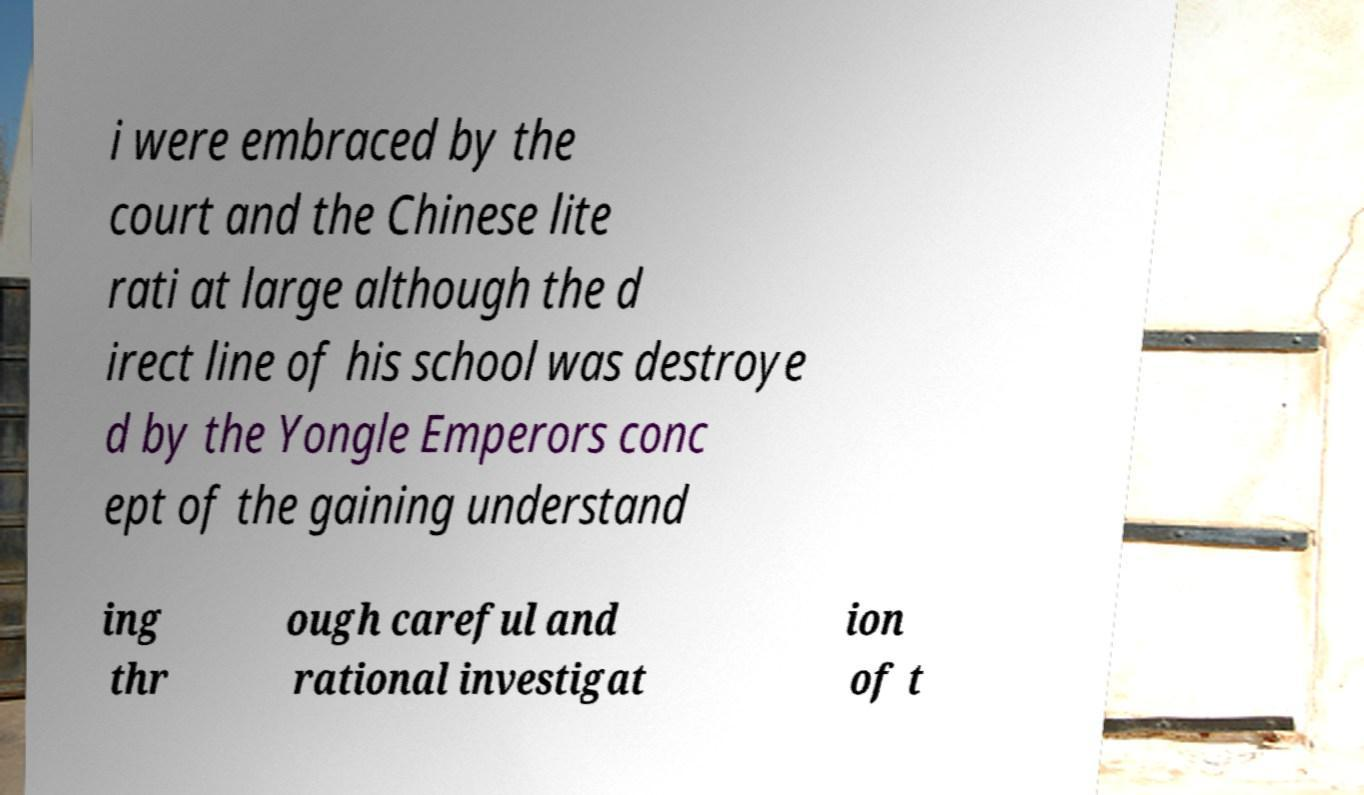Can you read and provide the text displayed in the image?This photo seems to have some interesting text. Can you extract and type it out for me? i were embraced by the court and the Chinese lite rati at large although the d irect line of his school was destroye d by the Yongle Emperors conc ept of the gaining understand ing thr ough careful and rational investigat ion of t 